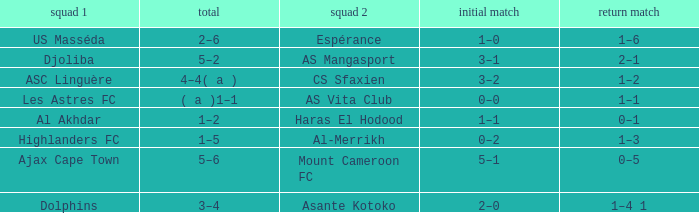What is the 2nd leg of team 1 Dolphins? 1–4 1. 